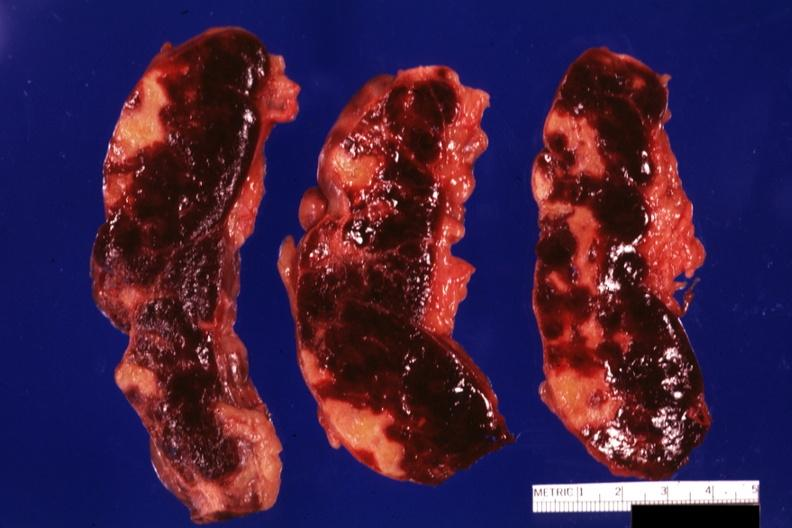where is this part in?
Answer the question using a single word or phrase. Spleen 